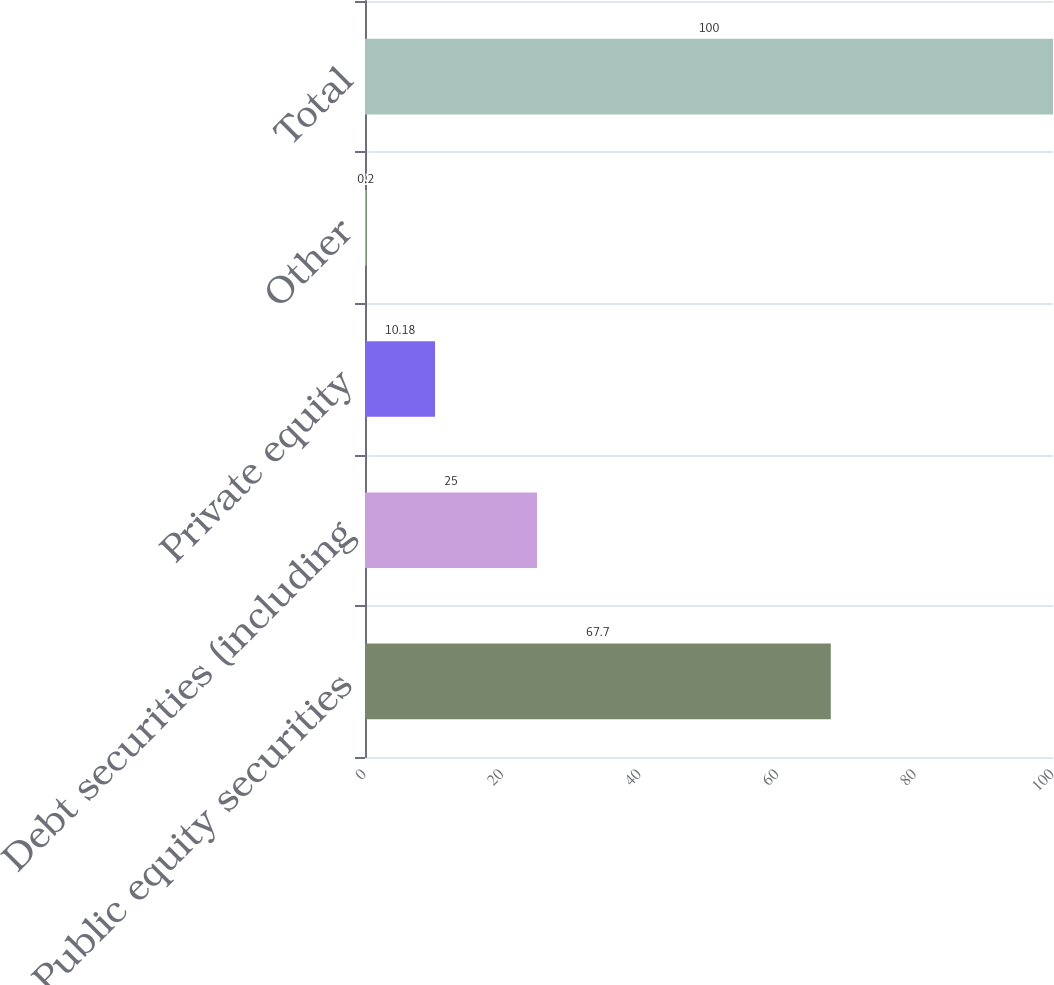Convert chart to OTSL. <chart><loc_0><loc_0><loc_500><loc_500><bar_chart><fcel>Public equity securities<fcel>Debt securities (including<fcel>Private equity<fcel>Other<fcel>Total<nl><fcel>67.7<fcel>25<fcel>10.18<fcel>0.2<fcel>100<nl></chart> 